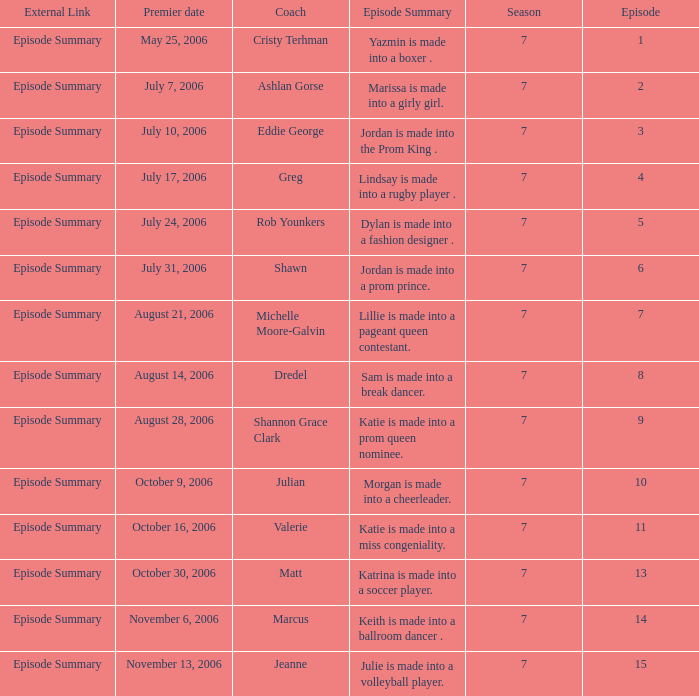How many episodes have Valerie? 1.0. 